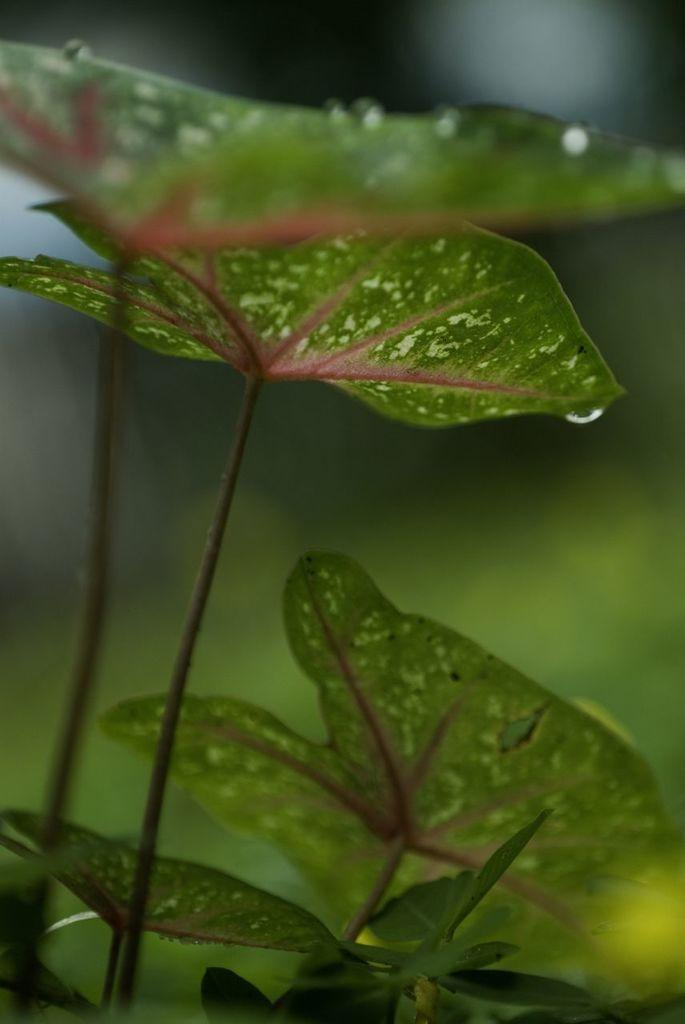What type of vegetation can be seen in the image? There are leaves in the image. Can you describe the background of the image? The background of the image is blurred. What type of coast can be seen in the image? There is no coast present in the image; it features leaves and a blurred background. What part of the plant is visible in the image? The image does not show a specific part of the plant, only leaves. 